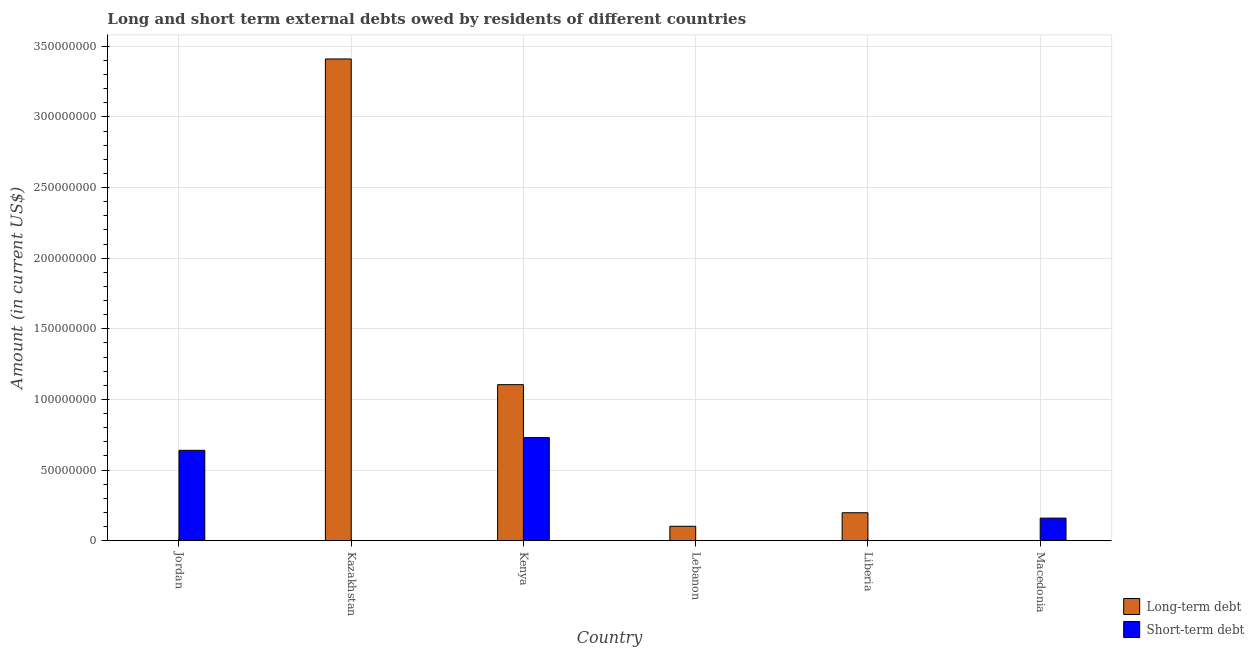Are the number of bars on each tick of the X-axis equal?
Provide a succinct answer. No. How many bars are there on the 1st tick from the right?
Your answer should be very brief. 1. What is the label of the 4th group of bars from the left?
Give a very brief answer. Lebanon. In how many cases, is the number of bars for a given country not equal to the number of legend labels?
Make the answer very short. 5. What is the long-term debts owed by residents in Lebanon?
Provide a short and direct response. 1.02e+07. Across all countries, what is the maximum long-term debts owed by residents?
Give a very brief answer. 3.41e+08. In which country was the long-term debts owed by residents maximum?
Ensure brevity in your answer.  Kazakhstan. What is the total long-term debts owed by residents in the graph?
Your answer should be very brief. 4.82e+08. What is the difference between the long-term debts owed by residents in Kazakhstan and that in Lebanon?
Your response must be concise. 3.31e+08. What is the difference between the short-term debts owed by residents in Kazakhstan and the long-term debts owed by residents in Jordan?
Provide a succinct answer. 0. What is the average short-term debts owed by residents per country?
Your answer should be compact. 2.55e+07. What is the difference between the short-term debts owed by residents and long-term debts owed by residents in Kenya?
Ensure brevity in your answer.  -3.75e+07. In how many countries, is the long-term debts owed by residents greater than 190000000 US$?
Provide a succinct answer. 1. What is the ratio of the long-term debts owed by residents in Kenya to that in Liberia?
Offer a very short reply. 5.58. Is the long-term debts owed by residents in Lebanon less than that in Liberia?
Offer a terse response. Yes. What is the difference between the highest and the second highest long-term debts owed by residents?
Provide a succinct answer. 2.31e+08. What is the difference between the highest and the lowest short-term debts owed by residents?
Offer a terse response. 7.30e+07. In how many countries, is the long-term debts owed by residents greater than the average long-term debts owed by residents taken over all countries?
Your answer should be compact. 2. How many bars are there?
Offer a very short reply. 7. Are all the bars in the graph horizontal?
Your answer should be very brief. No. How many countries are there in the graph?
Make the answer very short. 6. Are the values on the major ticks of Y-axis written in scientific E-notation?
Provide a short and direct response. No. How many legend labels are there?
Offer a very short reply. 2. What is the title of the graph?
Your response must be concise. Long and short term external debts owed by residents of different countries. Does "Unregistered firms" appear as one of the legend labels in the graph?
Provide a succinct answer. No. What is the label or title of the X-axis?
Your response must be concise. Country. What is the Amount (in current US$) in Short-term debt in Jordan?
Keep it short and to the point. 6.40e+07. What is the Amount (in current US$) of Long-term debt in Kazakhstan?
Make the answer very short. 3.41e+08. What is the Amount (in current US$) of Long-term debt in Kenya?
Provide a short and direct response. 1.10e+08. What is the Amount (in current US$) of Short-term debt in Kenya?
Offer a terse response. 7.30e+07. What is the Amount (in current US$) in Long-term debt in Lebanon?
Provide a succinct answer. 1.02e+07. What is the Amount (in current US$) in Long-term debt in Liberia?
Keep it short and to the point. 1.98e+07. What is the Amount (in current US$) of Long-term debt in Macedonia?
Keep it short and to the point. 0. What is the Amount (in current US$) of Short-term debt in Macedonia?
Your answer should be very brief. 1.60e+07. Across all countries, what is the maximum Amount (in current US$) of Long-term debt?
Your response must be concise. 3.41e+08. Across all countries, what is the maximum Amount (in current US$) of Short-term debt?
Your response must be concise. 7.30e+07. Across all countries, what is the minimum Amount (in current US$) of Long-term debt?
Offer a terse response. 0. What is the total Amount (in current US$) in Long-term debt in the graph?
Give a very brief answer. 4.82e+08. What is the total Amount (in current US$) in Short-term debt in the graph?
Offer a terse response. 1.53e+08. What is the difference between the Amount (in current US$) of Short-term debt in Jordan and that in Kenya?
Provide a short and direct response. -9.00e+06. What is the difference between the Amount (in current US$) of Short-term debt in Jordan and that in Macedonia?
Offer a terse response. 4.80e+07. What is the difference between the Amount (in current US$) of Long-term debt in Kazakhstan and that in Kenya?
Offer a terse response. 2.31e+08. What is the difference between the Amount (in current US$) in Long-term debt in Kazakhstan and that in Lebanon?
Give a very brief answer. 3.31e+08. What is the difference between the Amount (in current US$) of Long-term debt in Kazakhstan and that in Liberia?
Give a very brief answer. 3.21e+08. What is the difference between the Amount (in current US$) in Long-term debt in Kenya and that in Lebanon?
Offer a very short reply. 1.00e+08. What is the difference between the Amount (in current US$) of Long-term debt in Kenya and that in Liberia?
Your answer should be very brief. 9.07e+07. What is the difference between the Amount (in current US$) of Short-term debt in Kenya and that in Macedonia?
Your answer should be very brief. 5.70e+07. What is the difference between the Amount (in current US$) in Long-term debt in Lebanon and that in Liberia?
Give a very brief answer. -9.58e+06. What is the difference between the Amount (in current US$) of Long-term debt in Kazakhstan and the Amount (in current US$) of Short-term debt in Kenya?
Provide a short and direct response. 2.68e+08. What is the difference between the Amount (in current US$) in Long-term debt in Kazakhstan and the Amount (in current US$) in Short-term debt in Macedonia?
Provide a short and direct response. 3.25e+08. What is the difference between the Amount (in current US$) in Long-term debt in Kenya and the Amount (in current US$) in Short-term debt in Macedonia?
Give a very brief answer. 9.45e+07. What is the difference between the Amount (in current US$) in Long-term debt in Lebanon and the Amount (in current US$) in Short-term debt in Macedonia?
Offer a terse response. -5.78e+06. What is the difference between the Amount (in current US$) of Long-term debt in Liberia and the Amount (in current US$) of Short-term debt in Macedonia?
Provide a succinct answer. 3.80e+06. What is the average Amount (in current US$) of Long-term debt per country?
Provide a succinct answer. 8.03e+07. What is the average Amount (in current US$) of Short-term debt per country?
Offer a terse response. 2.55e+07. What is the difference between the Amount (in current US$) in Long-term debt and Amount (in current US$) in Short-term debt in Kenya?
Your response must be concise. 3.75e+07. What is the ratio of the Amount (in current US$) of Short-term debt in Jordan to that in Kenya?
Give a very brief answer. 0.88. What is the ratio of the Amount (in current US$) in Long-term debt in Kazakhstan to that in Kenya?
Keep it short and to the point. 3.09. What is the ratio of the Amount (in current US$) in Long-term debt in Kazakhstan to that in Lebanon?
Ensure brevity in your answer.  33.37. What is the ratio of the Amount (in current US$) in Long-term debt in Kazakhstan to that in Liberia?
Your response must be concise. 17.22. What is the ratio of the Amount (in current US$) of Long-term debt in Kenya to that in Lebanon?
Your response must be concise. 10.81. What is the ratio of the Amount (in current US$) in Long-term debt in Kenya to that in Liberia?
Provide a short and direct response. 5.58. What is the ratio of the Amount (in current US$) of Short-term debt in Kenya to that in Macedonia?
Make the answer very short. 4.56. What is the ratio of the Amount (in current US$) in Long-term debt in Lebanon to that in Liberia?
Provide a succinct answer. 0.52. What is the difference between the highest and the second highest Amount (in current US$) in Long-term debt?
Your answer should be compact. 2.31e+08. What is the difference between the highest and the second highest Amount (in current US$) in Short-term debt?
Give a very brief answer. 9.00e+06. What is the difference between the highest and the lowest Amount (in current US$) of Long-term debt?
Your answer should be very brief. 3.41e+08. What is the difference between the highest and the lowest Amount (in current US$) of Short-term debt?
Give a very brief answer. 7.30e+07. 